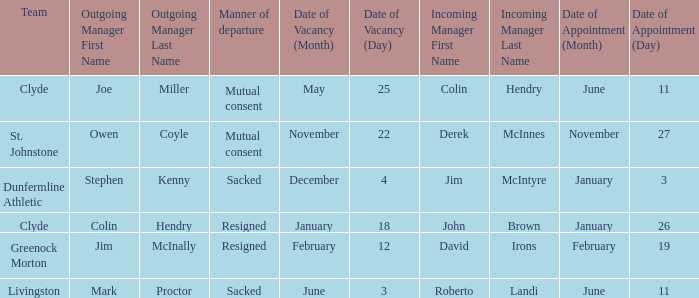Tell me the outgoing manager for 22 november date of vacancy Owen Coyle. 